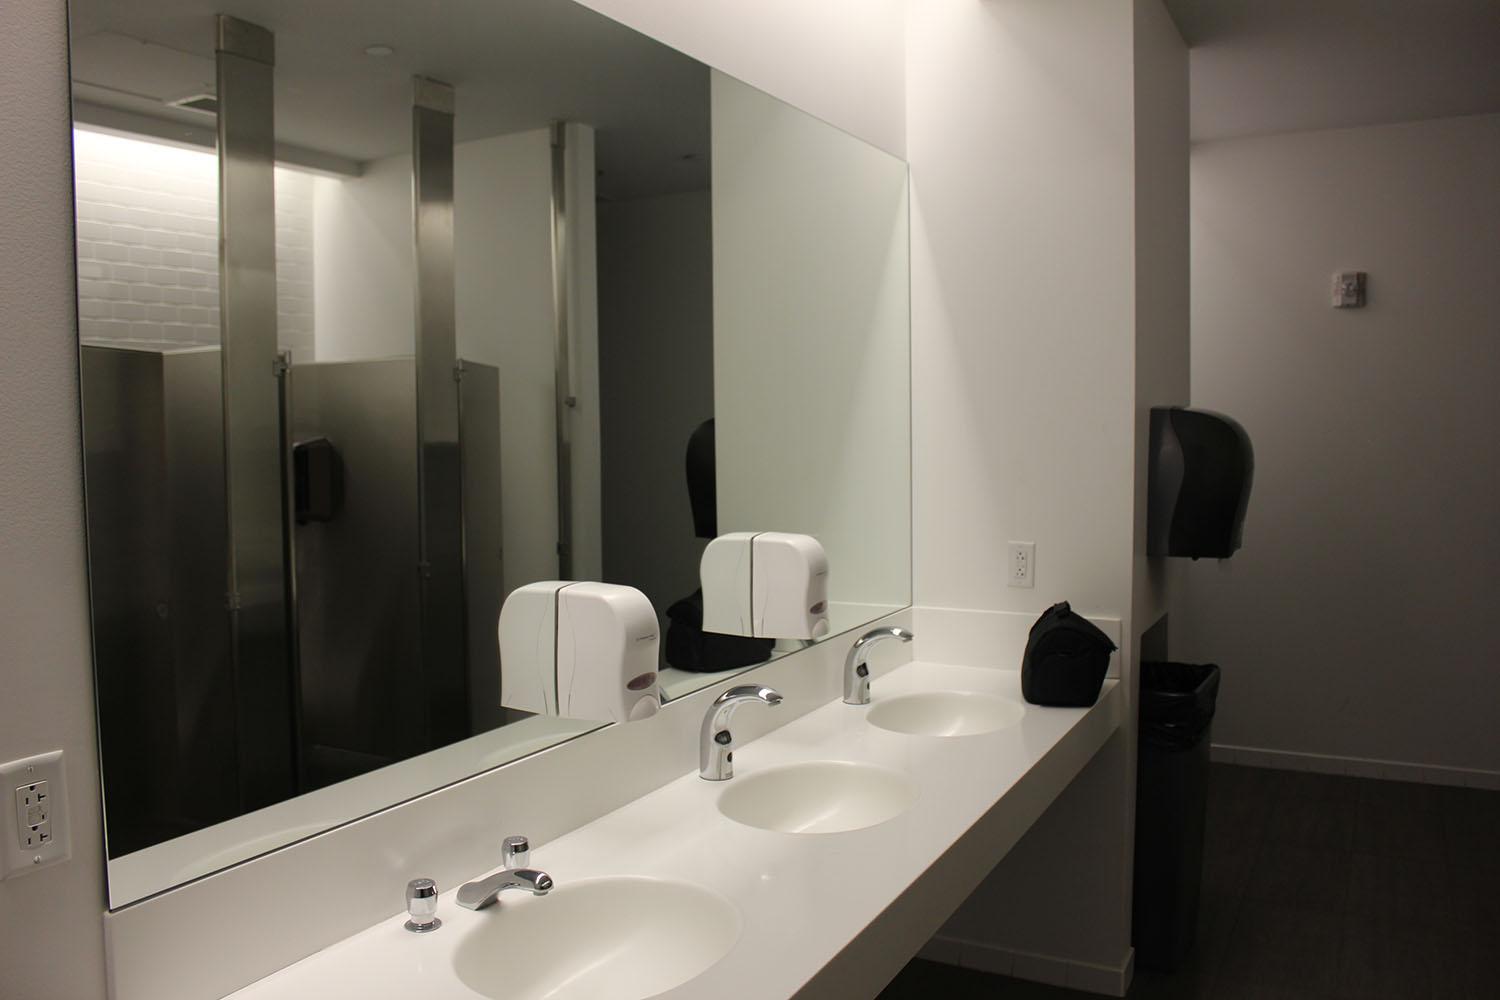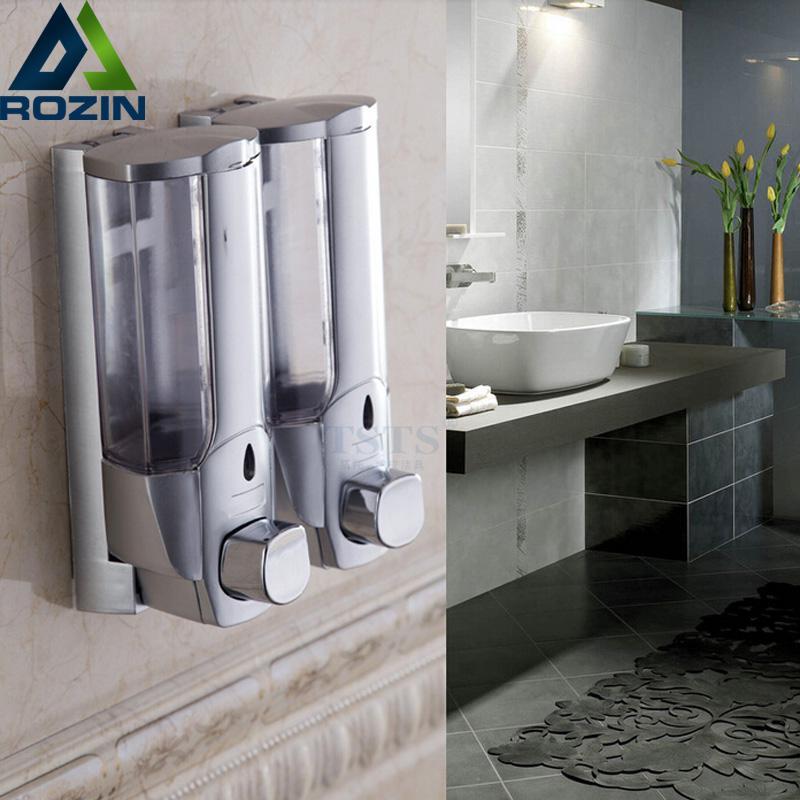The first image is the image on the left, the second image is the image on the right. Considering the images on both sides, is "Multiple pump-top dispensers can be seen sitting on top of surfaces instead of mounted." valid? Answer yes or no. No. The first image is the image on the left, the second image is the image on the right. Given the left and right images, does the statement "At least one soap dispenser has a spout pointing towards the left." hold true? Answer yes or no. No. 